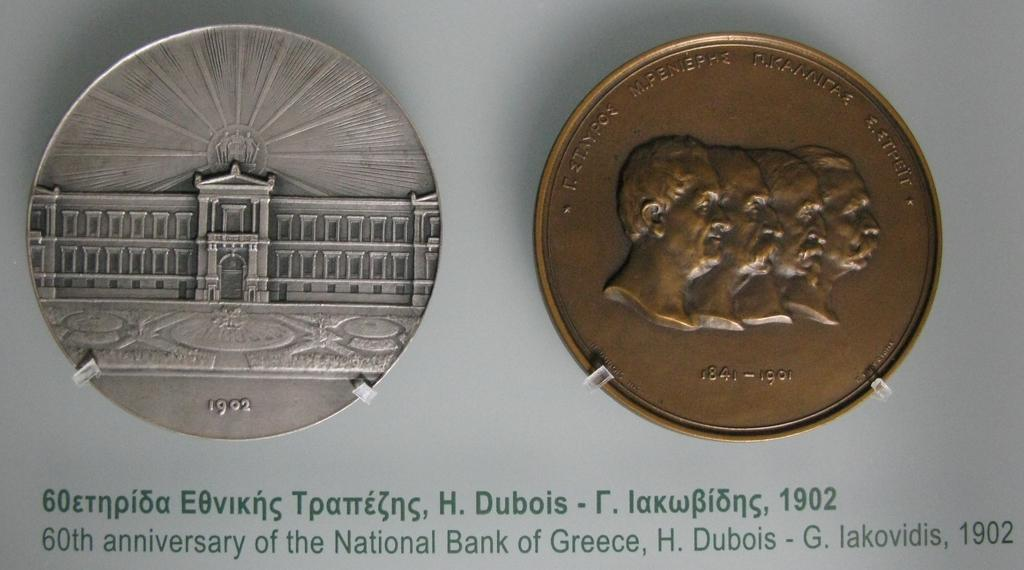<image>
Render a clear and concise summary of the photo. Two Greek coins from the early 1900s beside each other. 